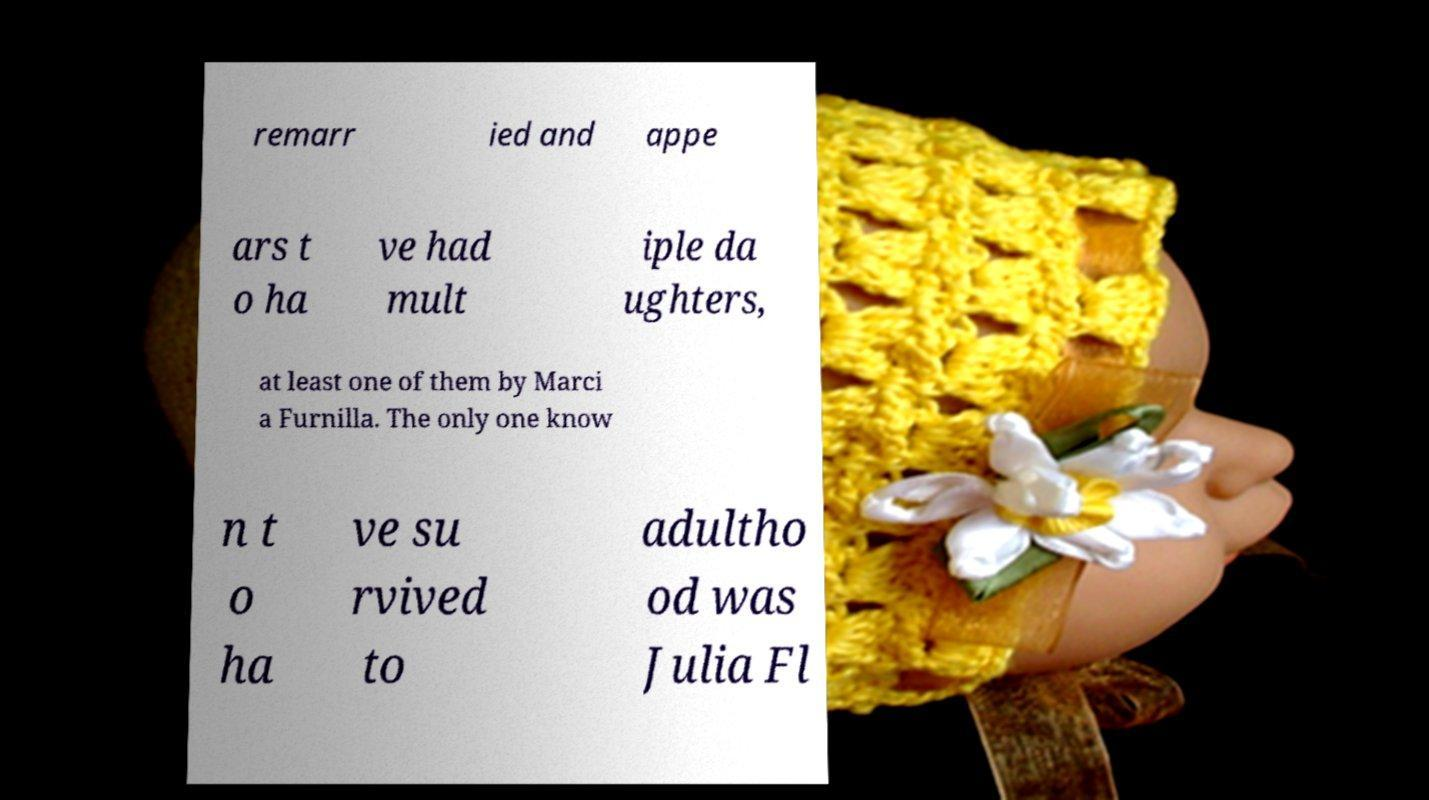For documentation purposes, I need the text within this image transcribed. Could you provide that? remarr ied and appe ars t o ha ve had mult iple da ughters, at least one of them by Marci a Furnilla. The only one know n t o ha ve su rvived to adultho od was Julia Fl 